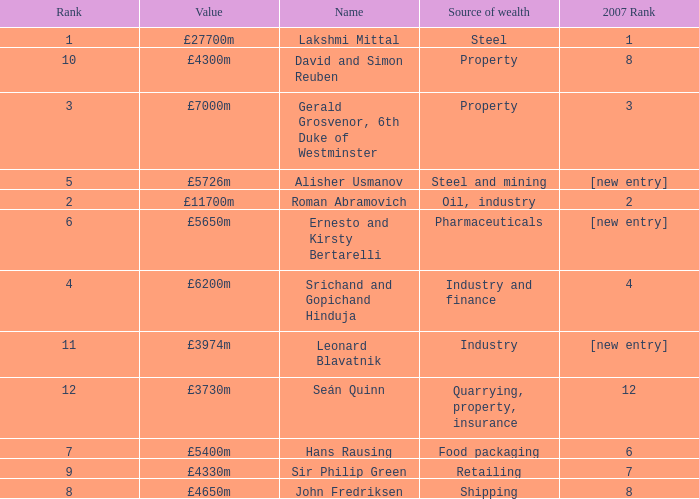Could you help me parse every detail presented in this table? {'header': ['Rank', 'Value', 'Name', 'Source of wealth', '2007 Rank'], 'rows': [['1', '£27700m', 'Lakshmi Mittal', 'Steel', '1'], ['10', '£4300m', 'David and Simon Reuben', 'Property', '8'], ['3', '£7000m', 'Gerald Grosvenor, 6th Duke of Westminster', 'Property', '3'], ['5', '£5726m', 'Alisher Usmanov', 'Steel and mining', '[new entry]'], ['2', '£11700m', 'Roman Abramovich', 'Oil, industry', '2'], ['6', '£5650m', 'Ernesto and Kirsty Bertarelli', 'Pharmaceuticals', '[new entry]'], ['4', '£6200m', 'Srichand and Gopichand Hinduja', 'Industry and finance', '4'], ['11', '£3974m', 'Leonard Blavatnik', 'Industry', '[new entry]'], ['12', '£3730m', 'Seán Quinn', 'Quarrying, property, insurance', '12'], ['7', '£5400m', 'Hans Rausing', 'Food packaging', '6'], ['9', '£4330m', 'Sir Philip Green', 'Retailing', '7'], ['8', '£4650m', 'John Fredriksen', 'Shipping', '8']]} What source of wealth has a value of £5726m? Steel and mining. 